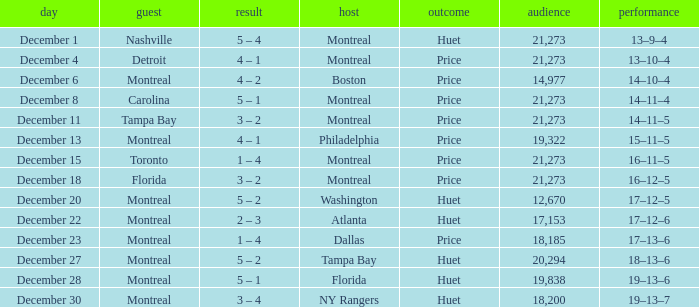What is the record on December 4? 13–10–4. 